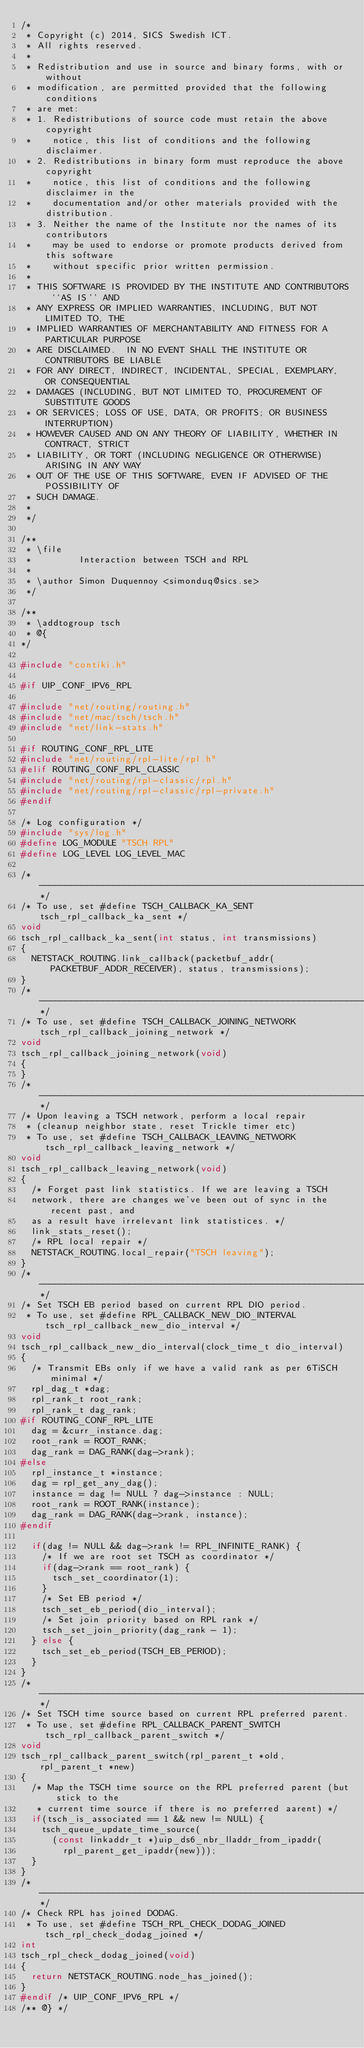<code> <loc_0><loc_0><loc_500><loc_500><_C_>/*
 * Copyright (c) 2014, SICS Swedish ICT.
 * All rights reserved.
 *
 * Redistribution and use in source and binary forms, with or without
 * modification, are permitted provided that the following conditions
 * are met:
 * 1. Redistributions of source code must retain the above copyright
 *    notice, this list of conditions and the following disclaimer.
 * 2. Redistributions in binary form must reproduce the above copyright
 *    notice, this list of conditions and the following disclaimer in the
 *    documentation and/or other materials provided with the distribution.
 * 3. Neither the name of the Institute nor the names of its contributors
 *    may be used to endorse or promote products derived from this software
 *    without specific prior written permission.
 *
 * THIS SOFTWARE IS PROVIDED BY THE INSTITUTE AND CONTRIBUTORS ``AS IS'' AND
 * ANY EXPRESS OR IMPLIED WARRANTIES, INCLUDING, BUT NOT LIMITED TO, THE
 * IMPLIED WARRANTIES OF MERCHANTABILITY AND FITNESS FOR A PARTICULAR PURPOSE
 * ARE DISCLAIMED.  IN NO EVENT SHALL THE INSTITUTE OR CONTRIBUTORS BE LIABLE
 * FOR ANY DIRECT, INDIRECT, INCIDENTAL, SPECIAL, EXEMPLARY, OR CONSEQUENTIAL
 * DAMAGES (INCLUDING, BUT NOT LIMITED TO, PROCUREMENT OF SUBSTITUTE GOODS
 * OR SERVICES; LOSS OF USE, DATA, OR PROFITS; OR BUSINESS INTERRUPTION)
 * HOWEVER CAUSED AND ON ANY THEORY OF LIABILITY, WHETHER IN CONTRACT, STRICT
 * LIABILITY, OR TORT (INCLUDING NEGLIGENCE OR OTHERWISE) ARISING IN ANY WAY
 * OUT OF THE USE OF THIS SOFTWARE, EVEN IF ADVISED OF THE POSSIBILITY OF
 * SUCH DAMAGE.
 *
 */

/**
 * \file
 *         Interaction between TSCH and RPL
 *
 * \author Simon Duquennoy <simonduq@sics.se>
 */

/**
 * \addtogroup tsch
 * @{
*/

#include "contiki.h"

#if UIP_CONF_IPV6_RPL

#include "net/routing/routing.h"
#include "net/mac/tsch/tsch.h"
#include "net/link-stats.h"

#if ROUTING_CONF_RPL_LITE
#include "net/routing/rpl-lite/rpl.h"
#elif ROUTING_CONF_RPL_CLASSIC
#include "net/routing/rpl-classic/rpl.h"
#include "net/routing/rpl-classic/rpl-private.h"
#endif

/* Log configuration */
#include "sys/log.h"
#define LOG_MODULE "TSCH RPL"
#define LOG_LEVEL LOG_LEVEL_MAC

/*---------------------------------------------------------------------------*/
/* To use, set #define TSCH_CALLBACK_KA_SENT tsch_rpl_callback_ka_sent */
void
tsch_rpl_callback_ka_sent(int status, int transmissions)
{
  NETSTACK_ROUTING.link_callback(packetbuf_addr(PACKETBUF_ADDR_RECEIVER), status, transmissions);
}
/*---------------------------------------------------------------------------*/
/* To use, set #define TSCH_CALLBACK_JOINING_NETWORK tsch_rpl_callback_joining_network */
void
tsch_rpl_callback_joining_network(void)
{
}
/*---------------------------------------------------------------------------*/
/* Upon leaving a TSCH network, perform a local repair
 * (cleanup neighbor state, reset Trickle timer etc)
 * To use, set #define TSCH_CALLBACK_LEAVING_NETWORK tsch_rpl_callback_leaving_network */
void
tsch_rpl_callback_leaving_network(void)
{
  /* Forget past link statistics. If we are leaving a TSCH
  network, there are changes we've been out of sync in the recent past, and
  as a result have irrelevant link statistices. */
  link_stats_reset();
  /* RPL local repair */
  NETSTACK_ROUTING.local_repair("TSCH leaving");
}
/*---------------------------------------------------------------------------*/
/* Set TSCH EB period based on current RPL DIO period.
 * To use, set #define RPL_CALLBACK_NEW_DIO_INTERVAL tsch_rpl_callback_new_dio_interval */
void
tsch_rpl_callback_new_dio_interval(clock_time_t dio_interval)
{
  /* Transmit EBs only if we have a valid rank as per 6TiSCH minimal */
  rpl_dag_t *dag;
  rpl_rank_t root_rank;
  rpl_rank_t dag_rank;
#if ROUTING_CONF_RPL_LITE
  dag = &curr_instance.dag;
  root_rank = ROOT_RANK;
  dag_rank = DAG_RANK(dag->rank);
#else
  rpl_instance_t *instance;
  dag = rpl_get_any_dag();
  instance = dag != NULL ? dag->instance : NULL;
  root_rank = ROOT_RANK(instance);
  dag_rank = DAG_RANK(dag->rank, instance);
#endif

  if(dag != NULL && dag->rank != RPL_INFINITE_RANK) {
    /* If we are root set TSCH as coordinator */
    if(dag->rank == root_rank) {
      tsch_set_coordinator(1);
    }
    /* Set EB period */
    tsch_set_eb_period(dio_interval);
    /* Set join priority based on RPL rank */
    tsch_set_join_priority(dag_rank - 1);
  } else {
    tsch_set_eb_period(TSCH_EB_PERIOD);
  }
}
/*---------------------------------------------------------------------------*/
/* Set TSCH time source based on current RPL preferred parent.
 * To use, set #define RPL_CALLBACK_PARENT_SWITCH tsch_rpl_callback_parent_switch */
void
tsch_rpl_callback_parent_switch(rpl_parent_t *old, rpl_parent_t *new)
{
  /* Map the TSCH time source on the RPL preferred parent (but stick to the
   * current time source if there is no preferred aarent) */
  if(tsch_is_associated == 1 && new != NULL) {
    tsch_queue_update_time_source(
      (const linkaddr_t *)uip_ds6_nbr_lladdr_from_ipaddr(
        rpl_parent_get_ipaddr(new)));
  }
}
/*---------------------------------------------------------------------------*/
/* Check RPL has joined DODAG.
 * To use, set #define TSCH_RPL_CHECK_DODAG_JOINED tsch_rpl_check_dodag_joined */
int
tsch_rpl_check_dodag_joined(void)
{
  return NETSTACK_ROUTING.node_has_joined();
}
#endif /* UIP_CONF_IPV6_RPL */
/** @} */
</code> 